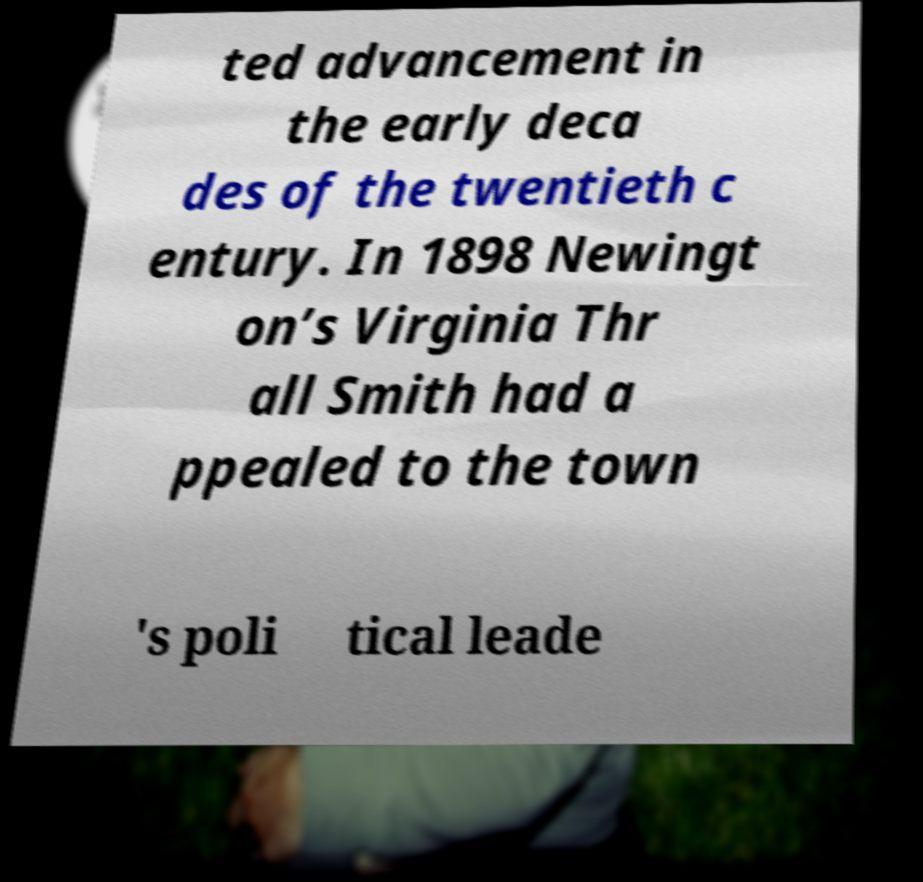Can you read and provide the text displayed in the image?This photo seems to have some interesting text. Can you extract and type it out for me? ted advancement in the early deca des of the twentieth c entury. In 1898 Newingt on’s Virginia Thr all Smith had a ppealed to the town 's poli tical leade 